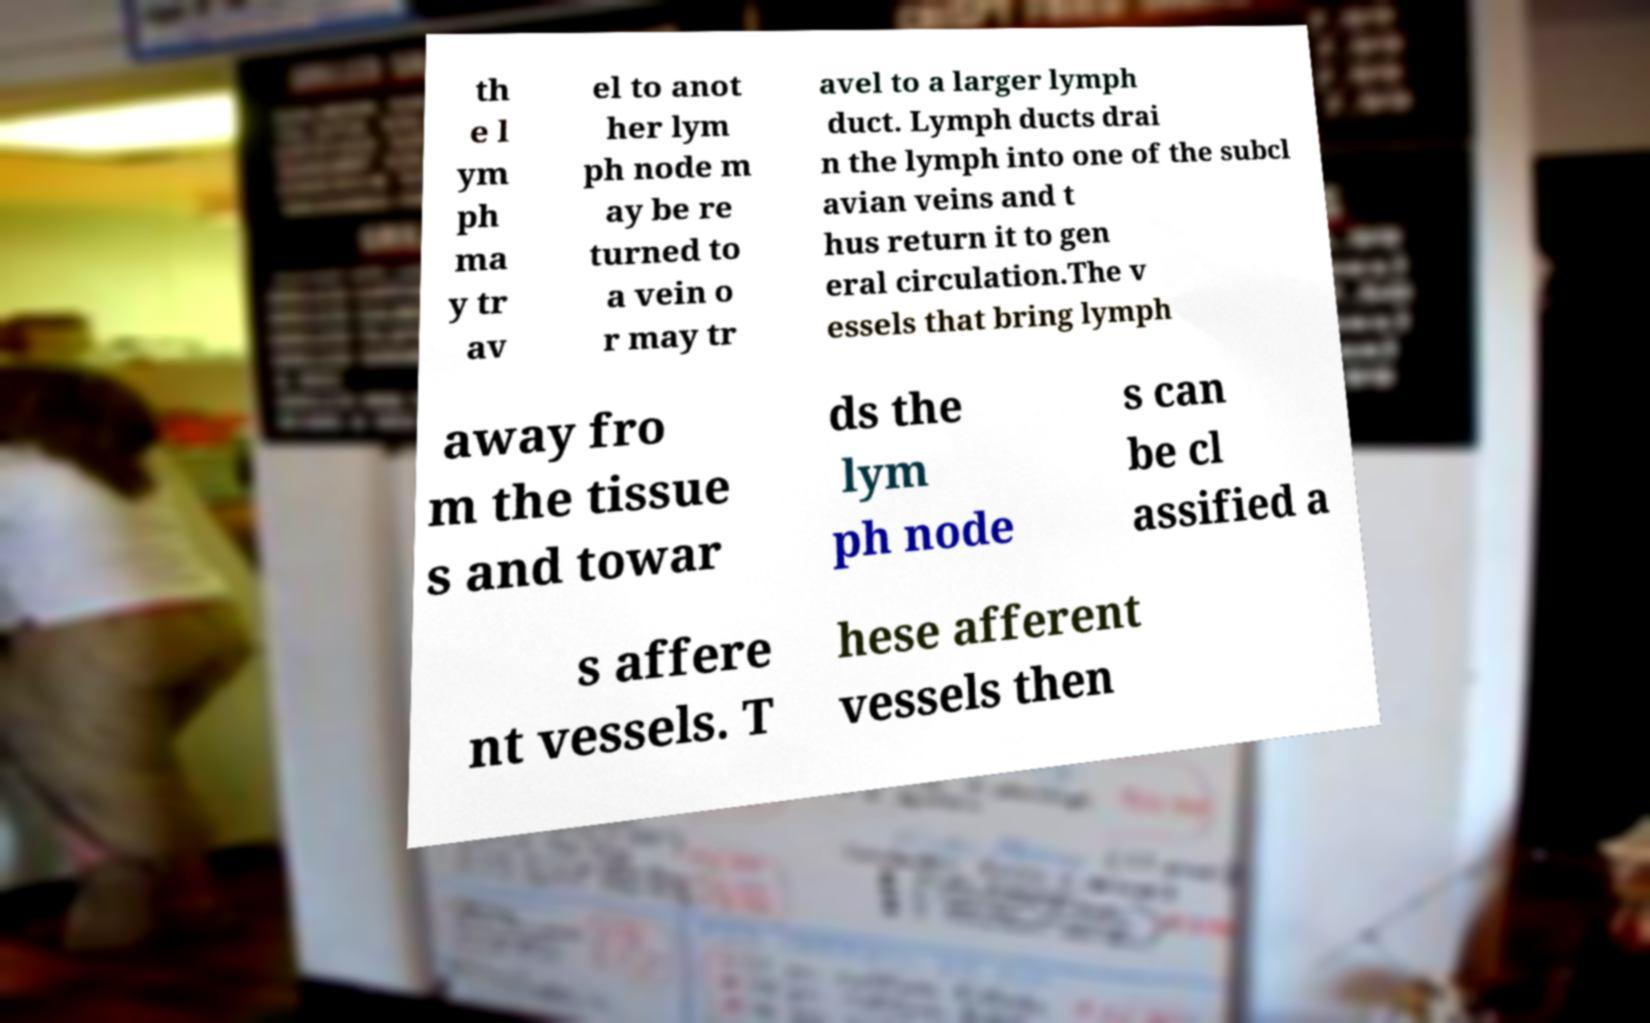What messages or text are displayed in this image? I need them in a readable, typed format. th e l ym ph ma y tr av el to anot her lym ph node m ay be re turned to a vein o r may tr avel to a larger lymph duct. Lymph ducts drai n the lymph into one of the subcl avian veins and t hus return it to gen eral circulation.The v essels that bring lymph away fro m the tissue s and towar ds the lym ph node s can be cl assified a s affere nt vessels. T hese afferent vessels then 